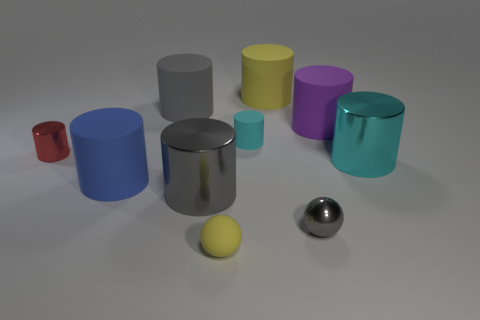Are there any large gray rubber cylinders on the right side of the purple matte cylinder?
Provide a succinct answer. No. The metal ball has what color?
Offer a terse response. Gray. There is a rubber sphere; is its color the same as the large object right of the large purple thing?
Offer a very short reply. No. Is there a purple matte object that has the same size as the red metallic thing?
Offer a terse response. No. What material is the cyan thing to the left of the cyan shiny cylinder?
Make the answer very short. Rubber. Are there an equal number of things that are behind the gray metallic cylinder and big objects in front of the blue matte cylinder?
Offer a very short reply. No. There is a gray object behind the big purple thing; is it the same size as the yellow rubber object in front of the purple thing?
Make the answer very short. No. How many small cylinders have the same color as the matte ball?
Keep it short and to the point. 0. There is a large cylinder that is the same color as the small matte sphere; what is it made of?
Your response must be concise. Rubber. Is the number of blue cylinders to the right of the red cylinder greater than the number of big red shiny things?
Offer a very short reply. Yes. 